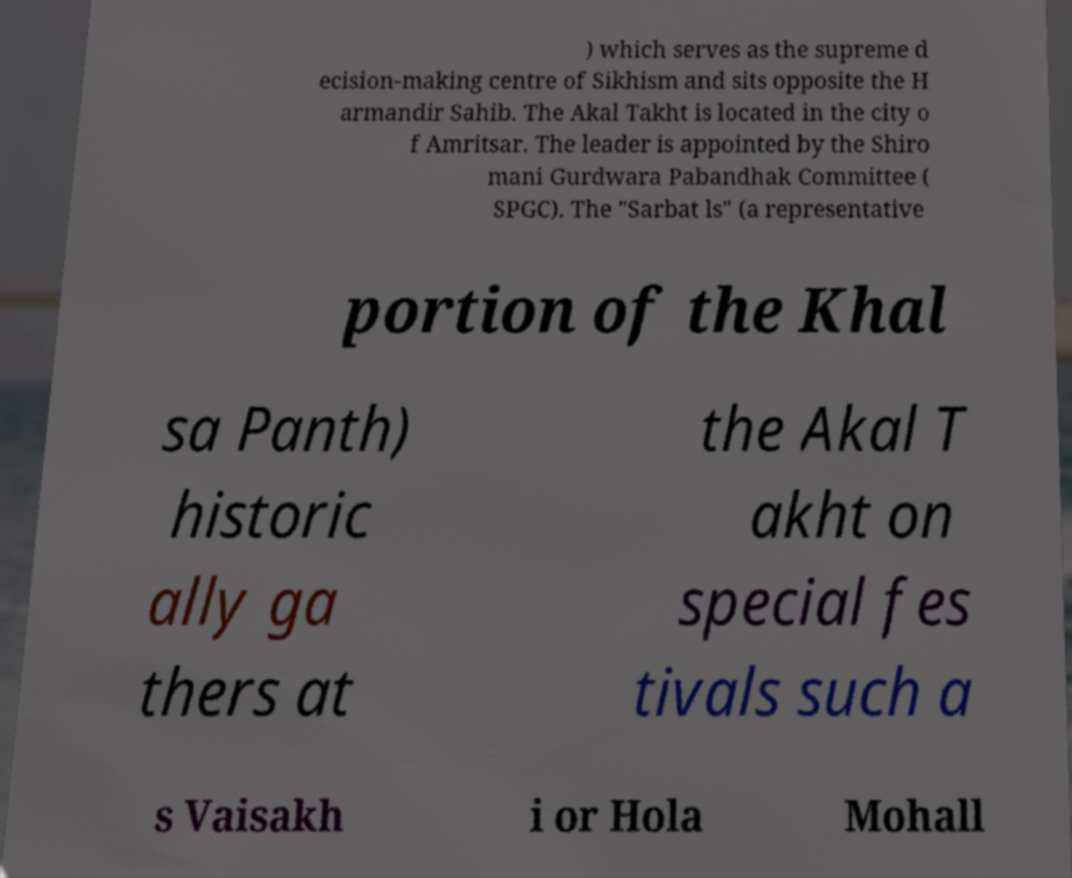Could you assist in decoding the text presented in this image and type it out clearly? ) which serves as the supreme d ecision-making centre of Sikhism and sits opposite the H armandir Sahib. The Akal Takht is located in the city o f Amritsar. The leader is appointed by the Shiro mani Gurdwara Pabandhak Committee ( SPGC). The "Sarbat ls" (a representative portion of the Khal sa Panth) historic ally ga thers at the Akal T akht on special fes tivals such a s Vaisakh i or Hola Mohall 